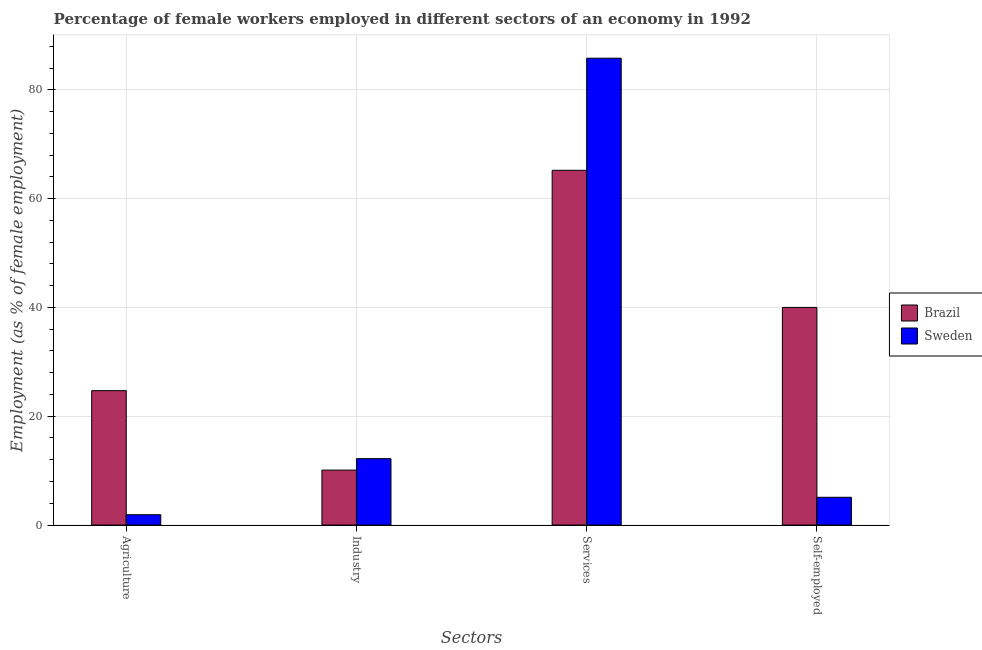How many different coloured bars are there?
Give a very brief answer. 2. Are the number of bars per tick equal to the number of legend labels?
Offer a very short reply. Yes. Are the number of bars on each tick of the X-axis equal?
Offer a terse response. Yes. How many bars are there on the 3rd tick from the left?
Your response must be concise. 2. How many bars are there on the 4th tick from the right?
Offer a terse response. 2. What is the label of the 1st group of bars from the left?
Provide a succinct answer. Agriculture. Across all countries, what is the maximum percentage of female workers in industry?
Your answer should be very brief. 12.2. Across all countries, what is the minimum percentage of female workers in industry?
Offer a terse response. 10.1. In which country was the percentage of female workers in industry maximum?
Keep it short and to the point. Sweden. What is the total percentage of self employed female workers in the graph?
Provide a short and direct response. 45.1. What is the difference between the percentage of female workers in services in Brazil and that in Sweden?
Your answer should be compact. -20.6. What is the difference between the percentage of female workers in services in Brazil and the percentage of female workers in industry in Sweden?
Ensure brevity in your answer.  53. What is the average percentage of self employed female workers per country?
Ensure brevity in your answer.  22.55. What is the difference between the percentage of self employed female workers and percentage of female workers in agriculture in Brazil?
Your answer should be compact. 15.3. In how many countries, is the percentage of self employed female workers greater than 28 %?
Make the answer very short. 1. What is the ratio of the percentage of female workers in services in Sweden to that in Brazil?
Offer a terse response. 1.32. What is the difference between the highest and the second highest percentage of female workers in agriculture?
Your answer should be compact. 22.8. What is the difference between the highest and the lowest percentage of self employed female workers?
Your answer should be very brief. 34.9. Is the sum of the percentage of female workers in services in Sweden and Brazil greater than the maximum percentage of female workers in industry across all countries?
Make the answer very short. Yes. What does the 2nd bar from the right in Self-employed represents?
Make the answer very short. Brazil. How many bars are there?
Give a very brief answer. 8. How many countries are there in the graph?
Provide a short and direct response. 2. What is the difference between two consecutive major ticks on the Y-axis?
Offer a very short reply. 20. Are the values on the major ticks of Y-axis written in scientific E-notation?
Offer a terse response. No. Does the graph contain any zero values?
Offer a terse response. No. Does the graph contain grids?
Make the answer very short. Yes. How many legend labels are there?
Keep it short and to the point. 2. What is the title of the graph?
Provide a short and direct response. Percentage of female workers employed in different sectors of an economy in 1992. Does "Kenya" appear as one of the legend labels in the graph?
Your response must be concise. No. What is the label or title of the X-axis?
Your answer should be very brief. Sectors. What is the label or title of the Y-axis?
Provide a succinct answer. Employment (as % of female employment). What is the Employment (as % of female employment) in Brazil in Agriculture?
Your answer should be compact. 24.7. What is the Employment (as % of female employment) in Sweden in Agriculture?
Provide a short and direct response. 1.9. What is the Employment (as % of female employment) in Brazil in Industry?
Provide a short and direct response. 10.1. What is the Employment (as % of female employment) of Sweden in Industry?
Make the answer very short. 12.2. What is the Employment (as % of female employment) of Brazil in Services?
Make the answer very short. 65.2. What is the Employment (as % of female employment) in Sweden in Services?
Provide a succinct answer. 85.8. What is the Employment (as % of female employment) of Sweden in Self-employed?
Keep it short and to the point. 5.1. Across all Sectors, what is the maximum Employment (as % of female employment) of Brazil?
Your answer should be compact. 65.2. Across all Sectors, what is the maximum Employment (as % of female employment) in Sweden?
Your response must be concise. 85.8. Across all Sectors, what is the minimum Employment (as % of female employment) in Brazil?
Provide a succinct answer. 10.1. Across all Sectors, what is the minimum Employment (as % of female employment) in Sweden?
Make the answer very short. 1.9. What is the total Employment (as % of female employment) of Brazil in the graph?
Provide a succinct answer. 140. What is the total Employment (as % of female employment) of Sweden in the graph?
Provide a succinct answer. 105. What is the difference between the Employment (as % of female employment) of Brazil in Agriculture and that in Industry?
Ensure brevity in your answer.  14.6. What is the difference between the Employment (as % of female employment) in Sweden in Agriculture and that in Industry?
Make the answer very short. -10.3. What is the difference between the Employment (as % of female employment) of Brazil in Agriculture and that in Services?
Your response must be concise. -40.5. What is the difference between the Employment (as % of female employment) in Sweden in Agriculture and that in Services?
Provide a short and direct response. -83.9. What is the difference between the Employment (as % of female employment) in Brazil in Agriculture and that in Self-employed?
Make the answer very short. -15.3. What is the difference between the Employment (as % of female employment) of Sweden in Agriculture and that in Self-employed?
Ensure brevity in your answer.  -3.2. What is the difference between the Employment (as % of female employment) of Brazil in Industry and that in Services?
Your answer should be very brief. -55.1. What is the difference between the Employment (as % of female employment) of Sweden in Industry and that in Services?
Your answer should be compact. -73.6. What is the difference between the Employment (as % of female employment) in Brazil in Industry and that in Self-employed?
Your answer should be compact. -29.9. What is the difference between the Employment (as % of female employment) in Brazil in Services and that in Self-employed?
Your answer should be very brief. 25.2. What is the difference between the Employment (as % of female employment) of Sweden in Services and that in Self-employed?
Keep it short and to the point. 80.7. What is the difference between the Employment (as % of female employment) of Brazil in Agriculture and the Employment (as % of female employment) of Sweden in Industry?
Offer a very short reply. 12.5. What is the difference between the Employment (as % of female employment) in Brazil in Agriculture and the Employment (as % of female employment) in Sweden in Services?
Offer a very short reply. -61.1. What is the difference between the Employment (as % of female employment) of Brazil in Agriculture and the Employment (as % of female employment) of Sweden in Self-employed?
Your answer should be compact. 19.6. What is the difference between the Employment (as % of female employment) of Brazil in Industry and the Employment (as % of female employment) of Sweden in Services?
Ensure brevity in your answer.  -75.7. What is the difference between the Employment (as % of female employment) of Brazil in Services and the Employment (as % of female employment) of Sweden in Self-employed?
Make the answer very short. 60.1. What is the average Employment (as % of female employment) of Sweden per Sectors?
Provide a succinct answer. 26.25. What is the difference between the Employment (as % of female employment) in Brazil and Employment (as % of female employment) in Sweden in Agriculture?
Your answer should be very brief. 22.8. What is the difference between the Employment (as % of female employment) in Brazil and Employment (as % of female employment) in Sweden in Services?
Keep it short and to the point. -20.6. What is the difference between the Employment (as % of female employment) of Brazil and Employment (as % of female employment) of Sweden in Self-employed?
Your answer should be compact. 34.9. What is the ratio of the Employment (as % of female employment) in Brazil in Agriculture to that in Industry?
Provide a short and direct response. 2.45. What is the ratio of the Employment (as % of female employment) of Sweden in Agriculture to that in Industry?
Ensure brevity in your answer.  0.16. What is the ratio of the Employment (as % of female employment) in Brazil in Agriculture to that in Services?
Keep it short and to the point. 0.38. What is the ratio of the Employment (as % of female employment) in Sweden in Agriculture to that in Services?
Keep it short and to the point. 0.02. What is the ratio of the Employment (as % of female employment) in Brazil in Agriculture to that in Self-employed?
Make the answer very short. 0.62. What is the ratio of the Employment (as % of female employment) of Sweden in Agriculture to that in Self-employed?
Provide a succinct answer. 0.37. What is the ratio of the Employment (as % of female employment) in Brazil in Industry to that in Services?
Give a very brief answer. 0.15. What is the ratio of the Employment (as % of female employment) of Sweden in Industry to that in Services?
Your answer should be very brief. 0.14. What is the ratio of the Employment (as % of female employment) of Brazil in Industry to that in Self-employed?
Ensure brevity in your answer.  0.25. What is the ratio of the Employment (as % of female employment) in Sweden in Industry to that in Self-employed?
Offer a very short reply. 2.39. What is the ratio of the Employment (as % of female employment) in Brazil in Services to that in Self-employed?
Provide a succinct answer. 1.63. What is the ratio of the Employment (as % of female employment) of Sweden in Services to that in Self-employed?
Provide a short and direct response. 16.82. What is the difference between the highest and the second highest Employment (as % of female employment) in Brazil?
Offer a very short reply. 25.2. What is the difference between the highest and the second highest Employment (as % of female employment) of Sweden?
Offer a terse response. 73.6. What is the difference between the highest and the lowest Employment (as % of female employment) in Brazil?
Provide a short and direct response. 55.1. What is the difference between the highest and the lowest Employment (as % of female employment) in Sweden?
Your answer should be compact. 83.9. 